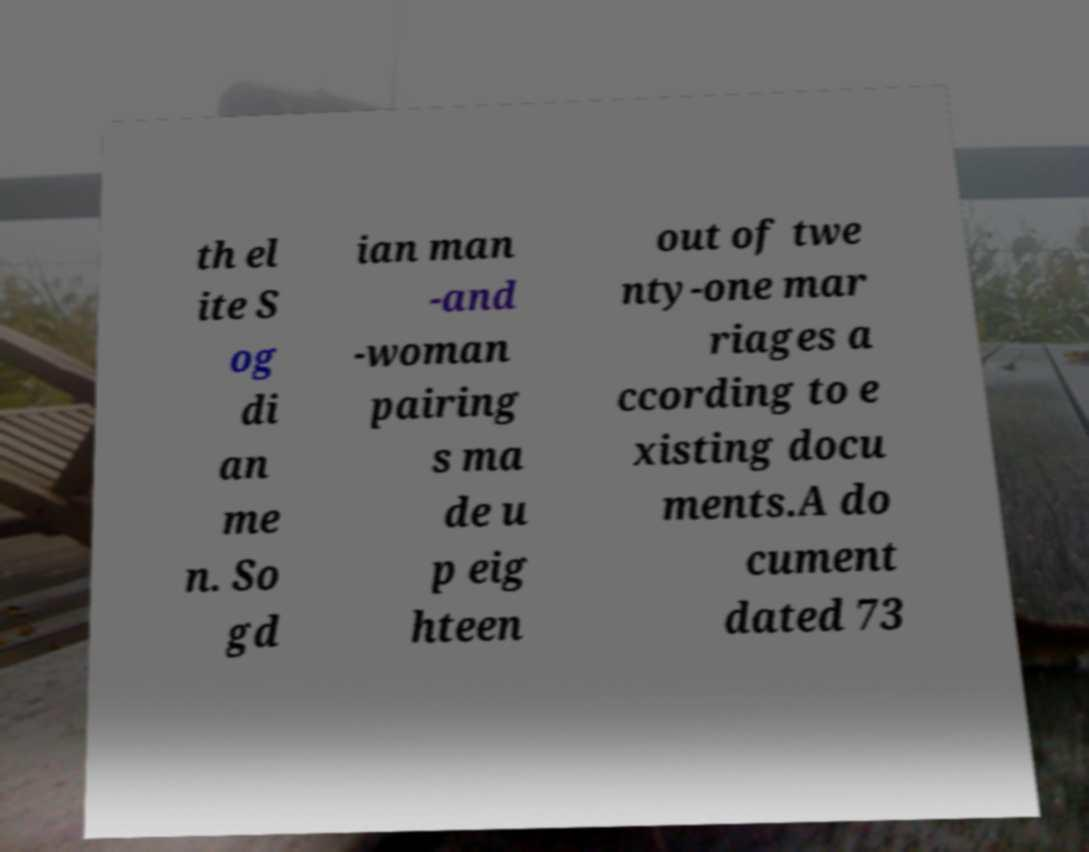Can you accurately transcribe the text from the provided image for me? th el ite S og di an me n. So gd ian man -and -woman pairing s ma de u p eig hteen out of twe nty-one mar riages a ccording to e xisting docu ments.A do cument dated 73 